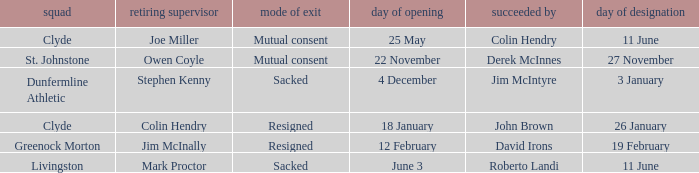Tell me the manner of departure for 3 january date of appointment Sacked. 